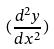Convert formula to latex. <formula><loc_0><loc_0><loc_500><loc_500>( \frac { d ^ { 2 } y } { d x ^ { 2 } } )</formula> 